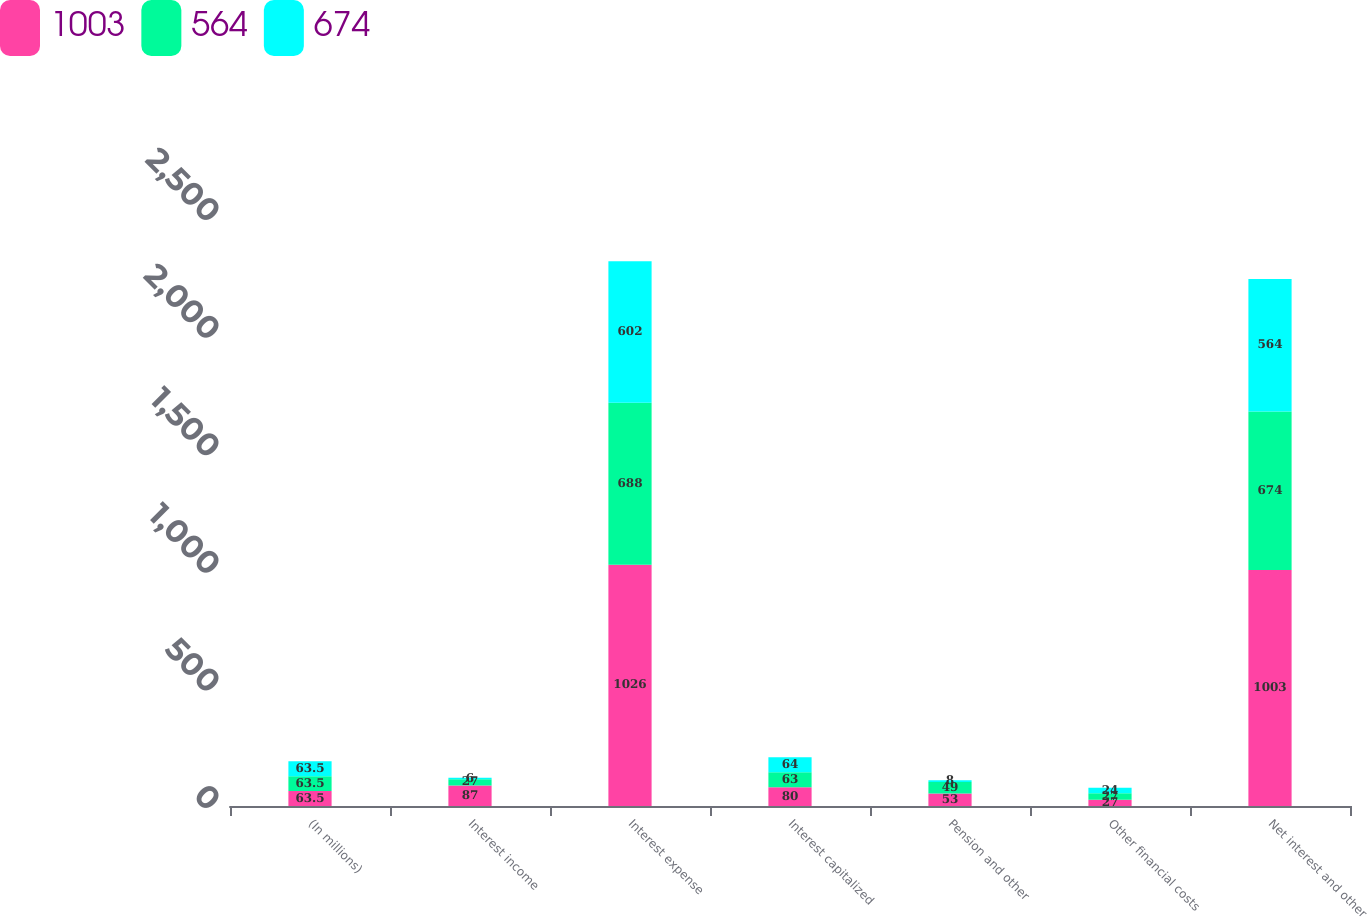Convert chart to OTSL. <chart><loc_0><loc_0><loc_500><loc_500><stacked_bar_chart><ecel><fcel>(In millions)<fcel>Interest income<fcel>Interest expense<fcel>Interest capitalized<fcel>Pension and other<fcel>Other financial costs<fcel>Net interest and other<nl><fcel>1003<fcel>63.5<fcel>87<fcel>1026<fcel>80<fcel>53<fcel>27<fcel>1003<nl><fcel>564<fcel>63.5<fcel>27<fcel>688<fcel>63<fcel>49<fcel>27<fcel>674<nl><fcel>674<fcel>63.5<fcel>6<fcel>602<fcel>64<fcel>8<fcel>24<fcel>564<nl></chart> 